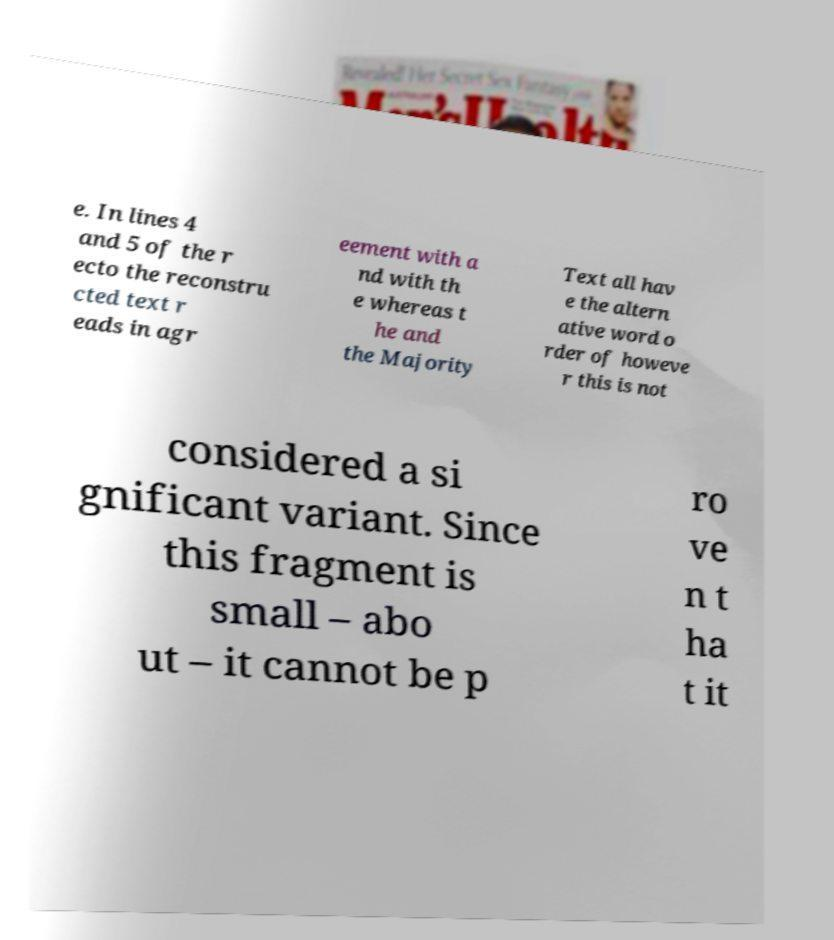I need the written content from this picture converted into text. Can you do that? e. In lines 4 and 5 of the r ecto the reconstru cted text r eads in agr eement with a nd with th e whereas t he and the Majority Text all hav e the altern ative word o rder of howeve r this is not considered a si gnificant variant. Since this fragment is small – abo ut – it cannot be p ro ve n t ha t it 